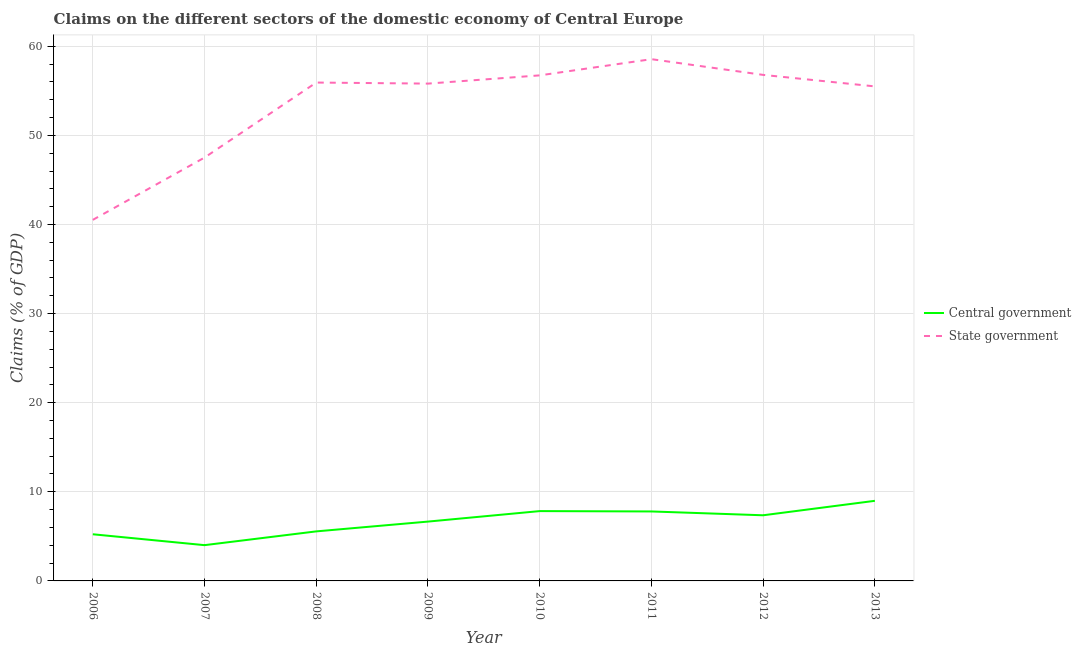How many different coloured lines are there?
Give a very brief answer. 2. What is the claims on central government in 2010?
Ensure brevity in your answer.  7.84. Across all years, what is the maximum claims on central government?
Your answer should be compact. 8.99. Across all years, what is the minimum claims on state government?
Keep it short and to the point. 40.52. In which year was the claims on central government maximum?
Give a very brief answer. 2013. What is the total claims on central government in the graph?
Keep it short and to the point. 53.45. What is the difference between the claims on central government in 2008 and that in 2013?
Offer a terse response. -3.43. What is the difference between the claims on central government in 2012 and the claims on state government in 2007?
Provide a short and direct response. -40.14. What is the average claims on central government per year?
Ensure brevity in your answer.  6.68. In the year 2009, what is the difference between the claims on central government and claims on state government?
Offer a terse response. -49.15. What is the ratio of the claims on state government in 2012 to that in 2013?
Give a very brief answer. 1.02. Is the claims on state government in 2006 less than that in 2012?
Your response must be concise. Yes. Is the difference between the claims on state government in 2008 and 2011 greater than the difference between the claims on central government in 2008 and 2011?
Provide a short and direct response. No. What is the difference between the highest and the second highest claims on central government?
Your answer should be compact. 1.15. What is the difference between the highest and the lowest claims on state government?
Offer a terse response. 18.03. In how many years, is the claims on central government greater than the average claims on central government taken over all years?
Your answer should be very brief. 4. Does the claims on central government monotonically increase over the years?
Offer a terse response. No. Is the claims on state government strictly greater than the claims on central government over the years?
Keep it short and to the point. Yes. Is the claims on central government strictly less than the claims on state government over the years?
Offer a very short reply. Yes. How many lines are there?
Your answer should be very brief. 2. How many years are there in the graph?
Make the answer very short. 8. What is the difference between two consecutive major ticks on the Y-axis?
Your answer should be very brief. 10. Does the graph contain any zero values?
Give a very brief answer. No. Does the graph contain grids?
Your response must be concise. Yes. How many legend labels are there?
Make the answer very short. 2. What is the title of the graph?
Your response must be concise. Claims on the different sectors of the domestic economy of Central Europe. Does "Broad money growth" appear as one of the legend labels in the graph?
Your answer should be very brief. No. What is the label or title of the Y-axis?
Ensure brevity in your answer.  Claims (% of GDP). What is the Claims (% of GDP) in Central government in 2006?
Your answer should be compact. 5.24. What is the Claims (% of GDP) of State government in 2006?
Make the answer very short. 40.52. What is the Claims (% of GDP) of Central government in 2007?
Keep it short and to the point. 4.01. What is the Claims (% of GDP) of State government in 2007?
Provide a short and direct response. 47.51. What is the Claims (% of GDP) in Central government in 2008?
Offer a terse response. 5.56. What is the Claims (% of GDP) of State government in 2008?
Your response must be concise. 55.93. What is the Claims (% of GDP) in Central government in 2009?
Your answer should be compact. 6.66. What is the Claims (% of GDP) of State government in 2009?
Provide a short and direct response. 55.81. What is the Claims (% of GDP) in Central government in 2010?
Provide a succinct answer. 7.84. What is the Claims (% of GDP) of State government in 2010?
Offer a very short reply. 56.73. What is the Claims (% of GDP) in Central government in 2011?
Keep it short and to the point. 7.8. What is the Claims (% of GDP) in State government in 2011?
Keep it short and to the point. 58.55. What is the Claims (% of GDP) of Central government in 2012?
Your answer should be very brief. 7.37. What is the Claims (% of GDP) in State government in 2012?
Offer a very short reply. 56.79. What is the Claims (% of GDP) of Central government in 2013?
Offer a terse response. 8.99. What is the Claims (% of GDP) in State government in 2013?
Keep it short and to the point. 55.5. Across all years, what is the maximum Claims (% of GDP) of Central government?
Provide a succinct answer. 8.99. Across all years, what is the maximum Claims (% of GDP) of State government?
Ensure brevity in your answer.  58.55. Across all years, what is the minimum Claims (% of GDP) of Central government?
Keep it short and to the point. 4.01. Across all years, what is the minimum Claims (% of GDP) of State government?
Offer a terse response. 40.52. What is the total Claims (% of GDP) in Central government in the graph?
Make the answer very short. 53.45. What is the total Claims (% of GDP) of State government in the graph?
Offer a very short reply. 427.35. What is the difference between the Claims (% of GDP) of Central government in 2006 and that in 2007?
Provide a succinct answer. 1.22. What is the difference between the Claims (% of GDP) of State government in 2006 and that in 2007?
Offer a terse response. -6.99. What is the difference between the Claims (% of GDP) of Central government in 2006 and that in 2008?
Offer a terse response. -0.32. What is the difference between the Claims (% of GDP) in State government in 2006 and that in 2008?
Offer a terse response. -15.41. What is the difference between the Claims (% of GDP) in Central government in 2006 and that in 2009?
Your response must be concise. -1.42. What is the difference between the Claims (% of GDP) of State government in 2006 and that in 2009?
Provide a short and direct response. -15.29. What is the difference between the Claims (% of GDP) in Central government in 2006 and that in 2010?
Offer a terse response. -2.6. What is the difference between the Claims (% of GDP) of State government in 2006 and that in 2010?
Your answer should be very brief. -16.21. What is the difference between the Claims (% of GDP) of Central government in 2006 and that in 2011?
Keep it short and to the point. -2.56. What is the difference between the Claims (% of GDP) in State government in 2006 and that in 2011?
Offer a very short reply. -18.03. What is the difference between the Claims (% of GDP) of Central government in 2006 and that in 2012?
Your answer should be compact. -2.13. What is the difference between the Claims (% of GDP) in State government in 2006 and that in 2012?
Offer a very short reply. -16.27. What is the difference between the Claims (% of GDP) in Central government in 2006 and that in 2013?
Your answer should be compact. -3.75. What is the difference between the Claims (% of GDP) in State government in 2006 and that in 2013?
Provide a short and direct response. -14.98. What is the difference between the Claims (% of GDP) of Central government in 2007 and that in 2008?
Provide a short and direct response. -1.55. What is the difference between the Claims (% of GDP) in State government in 2007 and that in 2008?
Give a very brief answer. -8.42. What is the difference between the Claims (% of GDP) of Central government in 2007 and that in 2009?
Offer a very short reply. -2.65. What is the difference between the Claims (% of GDP) in Central government in 2007 and that in 2010?
Provide a succinct answer. -3.82. What is the difference between the Claims (% of GDP) of State government in 2007 and that in 2010?
Your response must be concise. -9.22. What is the difference between the Claims (% of GDP) in Central government in 2007 and that in 2011?
Provide a short and direct response. -3.78. What is the difference between the Claims (% of GDP) in State government in 2007 and that in 2011?
Keep it short and to the point. -11.04. What is the difference between the Claims (% of GDP) in Central government in 2007 and that in 2012?
Offer a terse response. -3.35. What is the difference between the Claims (% of GDP) of State government in 2007 and that in 2012?
Make the answer very short. -9.28. What is the difference between the Claims (% of GDP) in Central government in 2007 and that in 2013?
Make the answer very short. -4.97. What is the difference between the Claims (% of GDP) in State government in 2007 and that in 2013?
Provide a succinct answer. -7.99. What is the difference between the Claims (% of GDP) of Central government in 2008 and that in 2009?
Offer a very short reply. -1.1. What is the difference between the Claims (% of GDP) in State government in 2008 and that in 2009?
Offer a terse response. 0.12. What is the difference between the Claims (% of GDP) of Central government in 2008 and that in 2010?
Provide a succinct answer. -2.28. What is the difference between the Claims (% of GDP) in State government in 2008 and that in 2010?
Provide a short and direct response. -0.81. What is the difference between the Claims (% of GDP) in Central government in 2008 and that in 2011?
Provide a short and direct response. -2.24. What is the difference between the Claims (% of GDP) in State government in 2008 and that in 2011?
Your answer should be compact. -2.62. What is the difference between the Claims (% of GDP) of Central government in 2008 and that in 2012?
Offer a very short reply. -1.81. What is the difference between the Claims (% of GDP) of State government in 2008 and that in 2012?
Offer a terse response. -0.86. What is the difference between the Claims (% of GDP) in Central government in 2008 and that in 2013?
Keep it short and to the point. -3.43. What is the difference between the Claims (% of GDP) of State government in 2008 and that in 2013?
Your response must be concise. 0.43. What is the difference between the Claims (% of GDP) in Central government in 2009 and that in 2010?
Your response must be concise. -1.18. What is the difference between the Claims (% of GDP) in State government in 2009 and that in 2010?
Keep it short and to the point. -0.92. What is the difference between the Claims (% of GDP) of Central government in 2009 and that in 2011?
Give a very brief answer. -1.14. What is the difference between the Claims (% of GDP) of State government in 2009 and that in 2011?
Your answer should be compact. -2.74. What is the difference between the Claims (% of GDP) in Central government in 2009 and that in 2012?
Your answer should be very brief. -0.71. What is the difference between the Claims (% of GDP) of State government in 2009 and that in 2012?
Your response must be concise. -0.98. What is the difference between the Claims (% of GDP) of Central government in 2009 and that in 2013?
Provide a succinct answer. -2.33. What is the difference between the Claims (% of GDP) of State government in 2009 and that in 2013?
Ensure brevity in your answer.  0.31. What is the difference between the Claims (% of GDP) of Central government in 2010 and that in 2011?
Provide a short and direct response. 0.04. What is the difference between the Claims (% of GDP) in State government in 2010 and that in 2011?
Your answer should be compact. -1.82. What is the difference between the Claims (% of GDP) of Central government in 2010 and that in 2012?
Provide a short and direct response. 0.47. What is the difference between the Claims (% of GDP) of State government in 2010 and that in 2012?
Provide a short and direct response. -0.05. What is the difference between the Claims (% of GDP) in Central government in 2010 and that in 2013?
Keep it short and to the point. -1.15. What is the difference between the Claims (% of GDP) of State government in 2010 and that in 2013?
Your answer should be very brief. 1.24. What is the difference between the Claims (% of GDP) of Central government in 2011 and that in 2012?
Keep it short and to the point. 0.43. What is the difference between the Claims (% of GDP) in State government in 2011 and that in 2012?
Offer a terse response. 1.76. What is the difference between the Claims (% of GDP) in Central government in 2011 and that in 2013?
Give a very brief answer. -1.19. What is the difference between the Claims (% of GDP) of State government in 2011 and that in 2013?
Your response must be concise. 3.05. What is the difference between the Claims (% of GDP) of Central government in 2012 and that in 2013?
Offer a very short reply. -1.62. What is the difference between the Claims (% of GDP) in State government in 2012 and that in 2013?
Offer a terse response. 1.29. What is the difference between the Claims (% of GDP) in Central government in 2006 and the Claims (% of GDP) in State government in 2007?
Your answer should be compact. -42.28. What is the difference between the Claims (% of GDP) of Central government in 2006 and the Claims (% of GDP) of State government in 2008?
Your response must be concise. -50.69. What is the difference between the Claims (% of GDP) in Central government in 2006 and the Claims (% of GDP) in State government in 2009?
Your answer should be compact. -50.58. What is the difference between the Claims (% of GDP) in Central government in 2006 and the Claims (% of GDP) in State government in 2010?
Make the answer very short. -51.5. What is the difference between the Claims (% of GDP) in Central government in 2006 and the Claims (% of GDP) in State government in 2011?
Your response must be concise. -53.32. What is the difference between the Claims (% of GDP) of Central government in 2006 and the Claims (% of GDP) of State government in 2012?
Offer a very short reply. -51.55. What is the difference between the Claims (% of GDP) of Central government in 2006 and the Claims (% of GDP) of State government in 2013?
Give a very brief answer. -50.26. What is the difference between the Claims (% of GDP) of Central government in 2007 and the Claims (% of GDP) of State government in 2008?
Ensure brevity in your answer.  -51.92. What is the difference between the Claims (% of GDP) of Central government in 2007 and the Claims (% of GDP) of State government in 2009?
Your answer should be very brief. -51.8. What is the difference between the Claims (% of GDP) in Central government in 2007 and the Claims (% of GDP) in State government in 2010?
Provide a succinct answer. -52.72. What is the difference between the Claims (% of GDP) of Central government in 2007 and the Claims (% of GDP) of State government in 2011?
Ensure brevity in your answer.  -54.54. What is the difference between the Claims (% of GDP) of Central government in 2007 and the Claims (% of GDP) of State government in 2012?
Provide a succinct answer. -52.77. What is the difference between the Claims (% of GDP) in Central government in 2007 and the Claims (% of GDP) in State government in 2013?
Your answer should be compact. -51.48. What is the difference between the Claims (% of GDP) in Central government in 2008 and the Claims (% of GDP) in State government in 2009?
Give a very brief answer. -50.25. What is the difference between the Claims (% of GDP) in Central government in 2008 and the Claims (% of GDP) in State government in 2010?
Make the answer very short. -51.18. What is the difference between the Claims (% of GDP) of Central government in 2008 and the Claims (% of GDP) of State government in 2011?
Ensure brevity in your answer.  -52.99. What is the difference between the Claims (% of GDP) of Central government in 2008 and the Claims (% of GDP) of State government in 2012?
Give a very brief answer. -51.23. What is the difference between the Claims (% of GDP) of Central government in 2008 and the Claims (% of GDP) of State government in 2013?
Your answer should be very brief. -49.94. What is the difference between the Claims (% of GDP) in Central government in 2009 and the Claims (% of GDP) in State government in 2010?
Offer a very short reply. -50.08. What is the difference between the Claims (% of GDP) of Central government in 2009 and the Claims (% of GDP) of State government in 2011?
Make the answer very short. -51.89. What is the difference between the Claims (% of GDP) of Central government in 2009 and the Claims (% of GDP) of State government in 2012?
Keep it short and to the point. -50.13. What is the difference between the Claims (% of GDP) of Central government in 2009 and the Claims (% of GDP) of State government in 2013?
Your response must be concise. -48.84. What is the difference between the Claims (% of GDP) in Central government in 2010 and the Claims (% of GDP) in State government in 2011?
Your answer should be very brief. -50.72. What is the difference between the Claims (% of GDP) of Central government in 2010 and the Claims (% of GDP) of State government in 2012?
Offer a very short reply. -48.95. What is the difference between the Claims (% of GDP) in Central government in 2010 and the Claims (% of GDP) in State government in 2013?
Ensure brevity in your answer.  -47.66. What is the difference between the Claims (% of GDP) of Central government in 2011 and the Claims (% of GDP) of State government in 2012?
Give a very brief answer. -48.99. What is the difference between the Claims (% of GDP) in Central government in 2011 and the Claims (% of GDP) in State government in 2013?
Offer a terse response. -47.7. What is the difference between the Claims (% of GDP) of Central government in 2012 and the Claims (% of GDP) of State government in 2013?
Your answer should be very brief. -48.13. What is the average Claims (% of GDP) of Central government per year?
Provide a short and direct response. 6.68. What is the average Claims (% of GDP) in State government per year?
Make the answer very short. 53.42. In the year 2006, what is the difference between the Claims (% of GDP) of Central government and Claims (% of GDP) of State government?
Your answer should be very brief. -35.28. In the year 2007, what is the difference between the Claims (% of GDP) of Central government and Claims (% of GDP) of State government?
Your answer should be compact. -43.5. In the year 2008, what is the difference between the Claims (% of GDP) in Central government and Claims (% of GDP) in State government?
Offer a terse response. -50.37. In the year 2009, what is the difference between the Claims (% of GDP) in Central government and Claims (% of GDP) in State government?
Your answer should be very brief. -49.15. In the year 2010, what is the difference between the Claims (% of GDP) in Central government and Claims (% of GDP) in State government?
Give a very brief answer. -48.9. In the year 2011, what is the difference between the Claims (% of GDP) in Central government and Claims (% of GDP) in State government?
Provide a short and direct response. -50.76. In the year 2012, what is the difference between the Claims (% of GDP) in Central government and Claims (% of GDP) in State government?
Keep it short and to the point. -49.42. In the year 2013, what is the difference between the Claims (% of GDP) in Central government and Claims (% of GDP) in State government?
Make the answer very short. -46.51. What is the ratio of the Claims (% of GDP) of Central government in 2006 to that in 2007?
Provide a succinct answer. 1.3. What is the ratio of the Claims (% of GDP) of State government in 2006 to that in 2007?
Your answer should be compact. 0.85. What is the ratio of the Claims (% of GDP) in Central government in 2006 to that in 2008?
Offer a very short reply. 0.94. What is the ratio of the Claims (% of GDP) in State government in 2006 to that in 2008?
Keep it short and to the point. 0.72. What is the ratio of the Claims (% of GDP) in Central government in 2006 to that in 2009?
Offer a very short reply. 0.79. What is the ratio of the Claims (% of GDP) in State government in 2006 to that in 2009?
Keep it short and to the point. 0.73. What is the ratio of the Claims (% of GDP) of Central government in 2006 to that in 2010?
Offer a terse response. 0.67. What is the ratio of the Claims (% of GDP) in State government in 2006 to that in 2010?
Make the answer very short. 0.71. What is the ratio of the Claims (% of GDP) in Central government in 2006 to that in 2011?
Ensure brevity in your answer.  0.67. What is the ratio of the Claims (% of GDP) of State government in 2006 to that in 2011?
Your answer should be compact. 0.69. What is the ratio of the Claims (% of GDP) in Central government in 2006 to that in 2012?
Make the answer very short. 0.71. What is the ratio of the Claims (% of GDP) of State government in 2006 to that in 2012?
Offer a terse response. 0.71. What is the ratio of the Claims (% of GDP) in Central government in 2006 to that in 2013?
Your answer should be compact. 0.58. What is the ratio of the Claims (% of GDP) of State government in 2006 to that in 2013?
Provide a short and direct response. 0.73. What is the ratio of the Claims (% of GDP) in Central government in 2007 to that in 2008?
Offer a terse response. 0.72. What is the ratio of the Claims (% of GDP) of State government in 2007 to that in 2008?
Your answer should be very brief. 0.85. What is the ratio of the Claims (% of GDP) in Central government in 2007 to that in 2009?
Provide a succinct answer. 0.6. What is the ratio of the Claims (% of GDP) in State government in 2007 to that in 2009?
Keep it short and to the point. 0.85. What is the ratio of the Claims (% of GDP) in Central government in 2007 to that in 2010?
Provide a succinct answer. 0.51. What is the ratio of the Claims (% of GDP) in State government in 2007 to that in 2010?
Offer a terse response. 0.84. What is the ratio of the Claims (% of GDP) of Central government in 2007 to that in 2011?
Your answer should be very brief. 0.51. What is the ratio of the Claims (% of GDP) of State government in 2007 to that in 2011?
Your answer should be very brief. 0.81. What is the ratio of the Claims (% of GDP) of Central government in 2007 to that in 2012?
Your response must be concise. 0.54. What is the ratio of the Claims (% of GDP) in State government in 2007 to that in 2012?
Provide a short and direct response. 0.84. What is the ratio of the Claims (% of GDP) of Central government in 2007 to that in 2013?
Offer a terse response. 0.45. What is the ratio of the Claims (% of GDP) of State government in 2007 to that in 2013?
Keep it short and to the point. 0.86. What is the ratio of the Claims (% of GDP) of Central government in 2008 to that in 2009?
Offer a terse response. 0.83. What is the ratio of the Claims (% of GDP) in Central government in 2008 to that in 2010?
Make the answer very short. 0.71. What is the ratio of the Claims (% of GDP) of State government in 2008 to that in 2010?
Offer a terse response. 0.99. What is the ratio of the Claims (% of GDP) in Central government in 2008 to that in 2011?
Ensure brevity in your answer.  0.71. What is the ratio of the Claims (% of GDP) in State government in 2008 to that in 2011?
Keep it short and to the point. 0.96. What is the ratio of the Claims (% of GDP) of Central government in 2008 to that in 2012?
Give a very brief answer. 0.75. What is the ratio of the Claims (% of GDP) of State government in 2008 to that in 2012?
Ensure brevity in your answer.  0.98. What is the ratio of the Claims (% of GDP) in Central government in 2008 to that in 2013?
Your answer should be compact. 0.62. What is the ratio of the Claims (% of GDP) of State government in 2008 to that in 2013?
Ensure brevity in your answer.  1.01. What is the ratio of the Claims (% of GDP) of Central government in 2009 to that in 2010?
Your answer should be very brief. 0.85. What is the ratio of the Claims (% of GDP) in State government in 2009 to that in 2010?
Offer a terse response. 0.98. What is the ratio of the Claims (% of GDP) in Central government in 2009 to that in 2011?
Make the answer very short. 0.85. What is the ratio of the Claims (% of GDP) in State government in 2009 to that in 2011?
Offer a very short reply. 0.95. What is the ratio of the Claims (% of GDP) in Central government in 2009 to that in 2012?
Your response must be concise. 0.9. What is the ratio of the Claims (% of GDP) of State government in 2009 to that in 2012?
Provide a short and direct response. 0.98. What is the ratio of the Claims (% of GDP) of Central government in 2009 to that in 2013?
Make the answer very short. 0.74. What is the ratio of the Claims (% of GDP) of State government in 2009 to that in 2013?
Your answer should be compact. 1.01. What is the ratio of the Claims (% of GDP) of Central government in 2010 to that in 2011?
Provide a succinct answer. 1.01. What is the ratio of the Claims (% of GDP) in State government in 2010 to that in 2011?
Offer a terse response. 0.97. What is the ratio of the Claims (% of GDP) in Central government in 2010 to that in 2012?
Your answer should be compact. 1.06. What is the ratio of the Claims (% of GDP) of State government in 2010 to that in 2012?
Keep it short and to the point. 1. What is the ratio of the Claims (% of GDP) of Central government in 2010 to that in 2013?
Give a very brief answer. 0.87. What is the ratio of the Claims (% of GDP) in State government in 2010 to that in 2013?
Your response must be concise. 1.02. What is the ratio of the Claims (% of GDP) in Central government in 2011 to that in 2012?
Provide a short and direct response. 1.06. What is the ratio of the Claims (% of GDP) in State government in 2011 to that in 2012?
Give a very brief answer. 1.03. What is the ratio of the Claims (% of GDP) of Central government in 2011 to that in 2013?
Provide a short and direct response. 0.87. What is the ratio of the Claims (% of GDP) in State government in 2011 to that in 2013?
Provide a succinct answer. 1.05. What is the ratio of the Claims (% of GDP) in Central government in 2012 to that in 2013?
Your answer should be compact. 0.82. What is the ratio of the Claims (% of GDP) in State government in 2012 to that in 2013?
Ensure brevity in your answer.  1.02. What is the difference between the highest and the second highest Claims (% of GDP) of Central government?
Keep it short and to the point. 1.15. What is the difference between the highest and the second highest Claims (% of GDP) in State government?
Offer a terse response. 1.76. What is the difference between the highest and the lowest Claims (% of GDP) of Central government?
Your answer should be compact. 4.97. What is the difference between the highest and the lowest Claims (% of GDP) of State government?
Give a very brief answer. 18.03. 